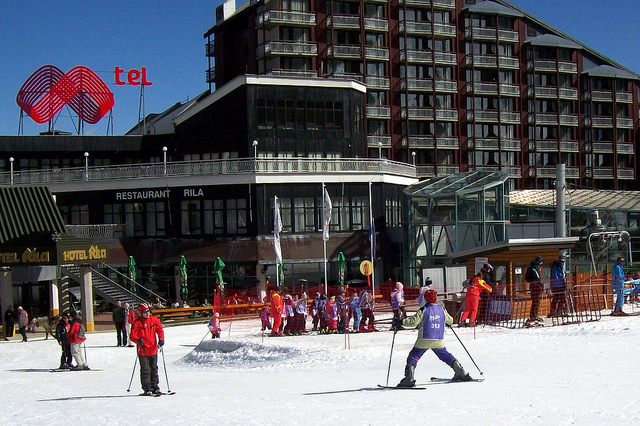Please transcribe the text in this image. AILA RESTAURANT HOTEL tel 